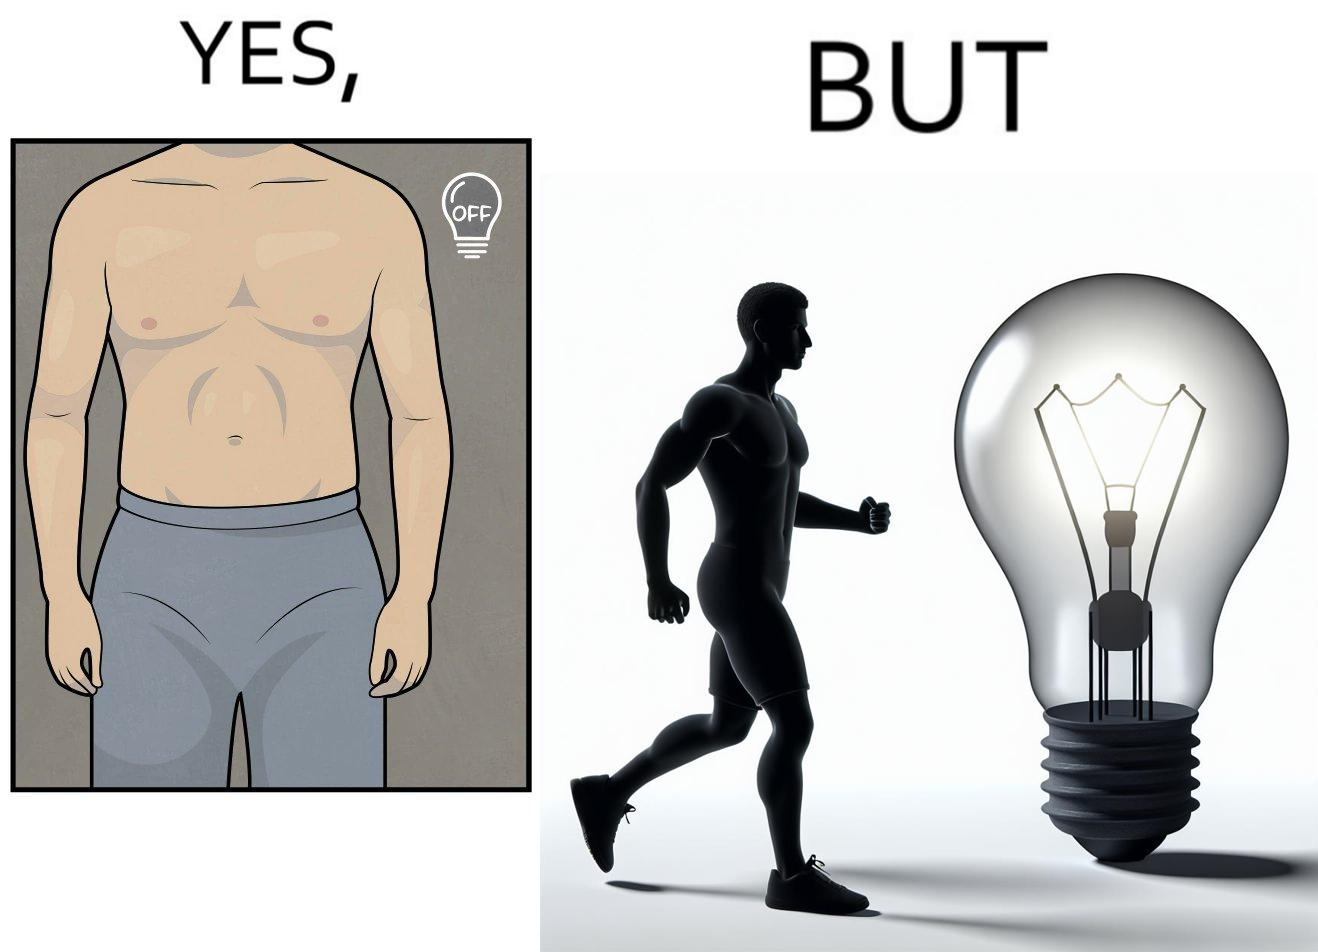What is shown in the left half versus the right half of this image? In the left part of the image: It shows a muscular male body with a turned off bulb In the right part of the image: It shows a non athletic male body with a turned on bulb 